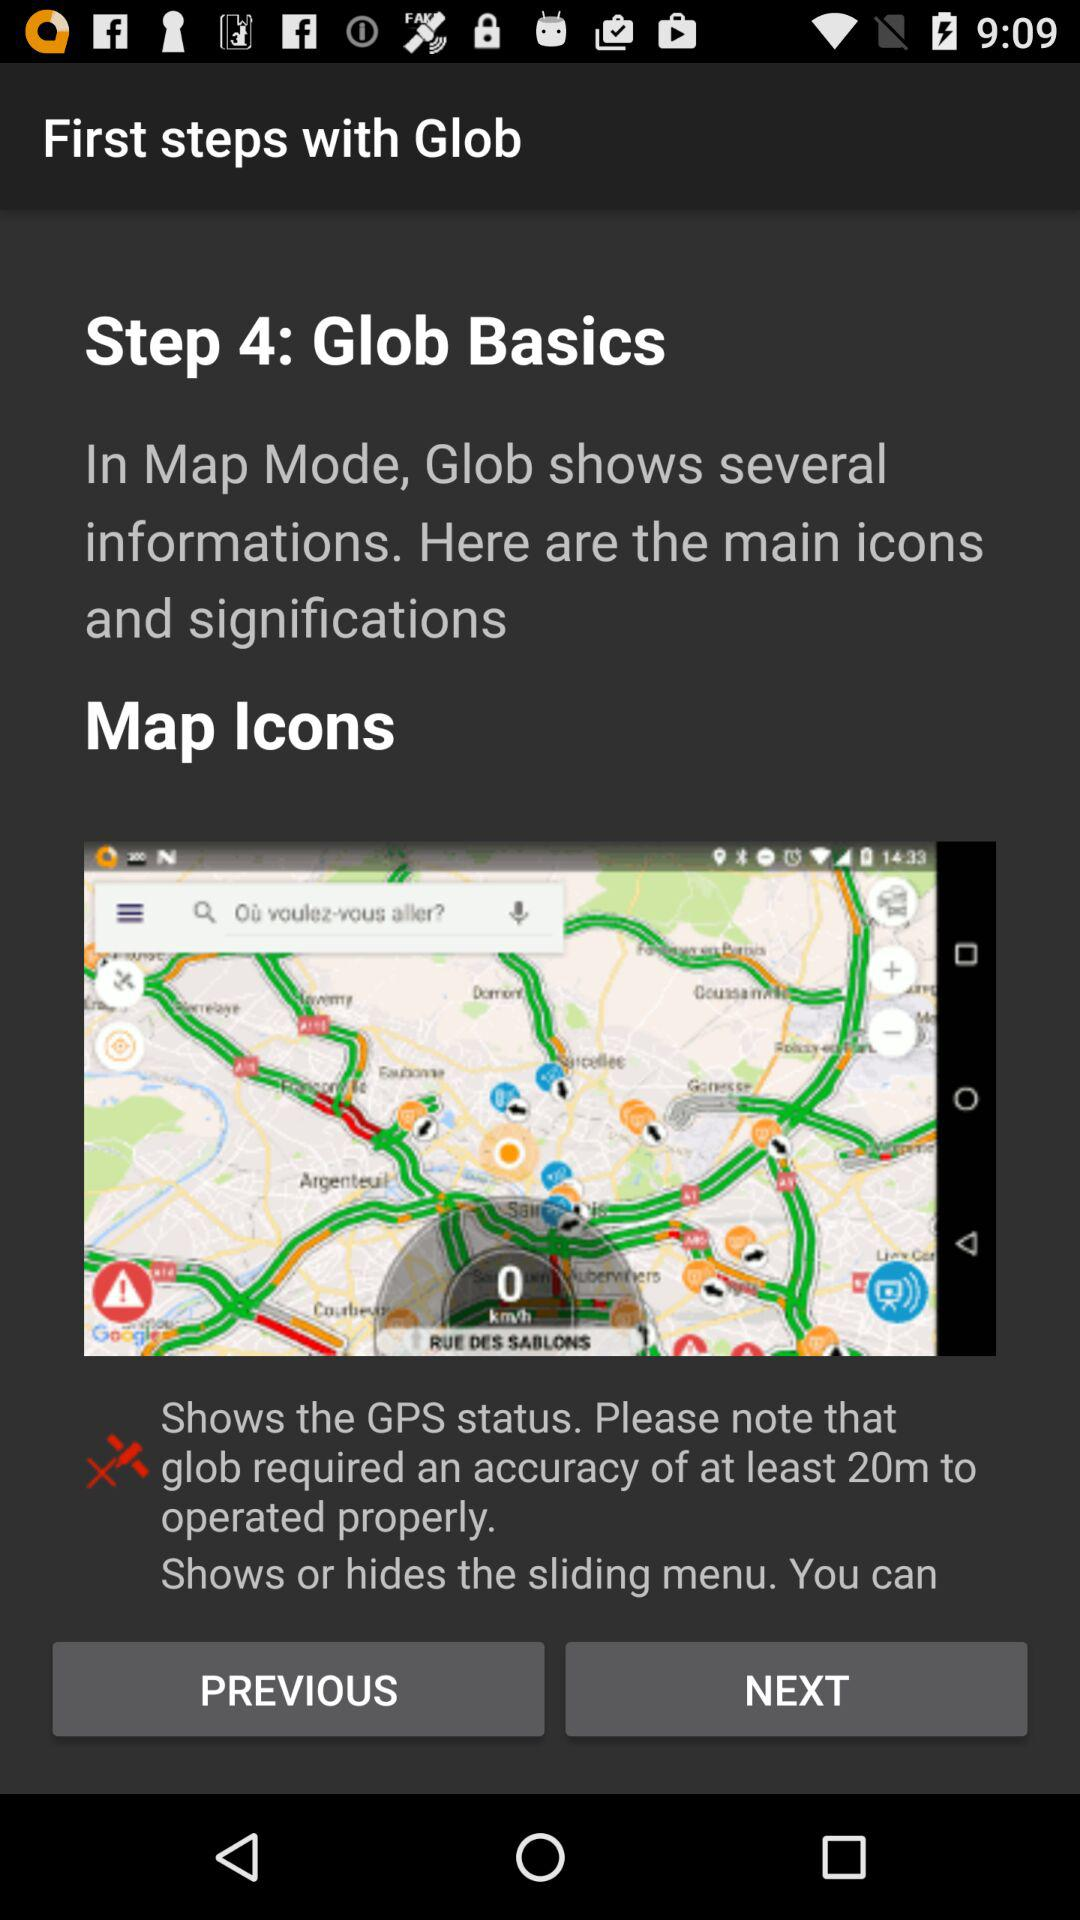What is the fourth step? The fourth step is "Glob Basics". 